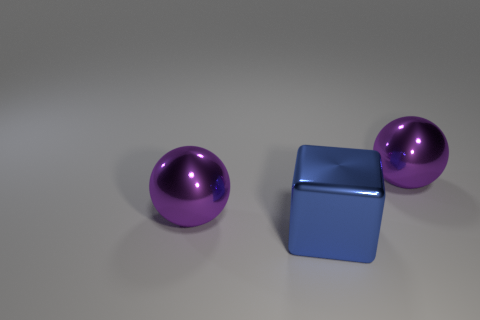There is a sphere that is to the left of the blue object; is it the same color as the big metallic thing that is to the right of the large blue cube?
Offer a very short reply. Yes. How many things are there?
Ensure brevity in your answer.  3. Are there any large metallic things in front of the large cube?
Offer a very short reply. No. Is the large ball to the right of the big blue block made of the same material as the sphere left of the block?
Your answer should be compact. Yes. Are there fewer big purple metallic things that are on the left side of the large cube than metal balls?
Provide a succinct answer. Yes. What color is the big metallic thing that is left of the large blue shiny block?
Offer a terse response. Purple. The ball that is behind the metal ball that is to the left of the blue object is made of what material?
Offer a terse response. Metal. Are there any other things of the same size as the blue shiny thing?
Your answer should be very brief. Yes. What number of things are either large metal objects that are right of the large cube or big things right of the large block?
Ensure brevity in your answer.  1. Does the purple metal thing on the right side of the large blue block have the same size as the purple object that is to the left of the big blue cube?
Your answer should be very brief. Yes. 